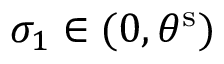<formula> <loc_0><loc_0><loc_500><loc_500>\sigma _ { 1 } \in ( 0 , { \theta } ^ { s } )</formula> 